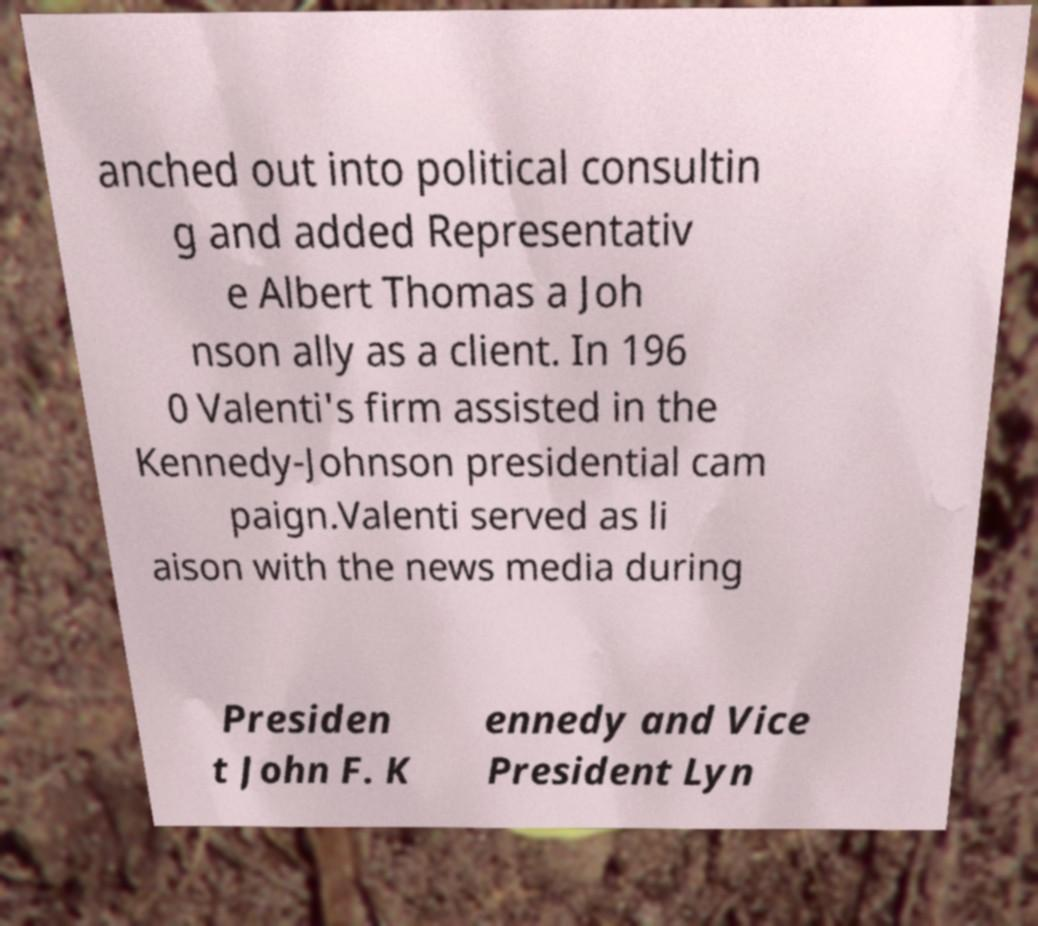Could you extract and type out the text from this image? anched out into political consultin g and added Representativ e Albert Thomas a Joh nson ally as a client. In 196 0 Valenti's firm assisted in the Kennedy-Johnson presidential cam paign.Valenti served as li aison with the news media during Presiden t John F. K ennedy and Vice President Lyn 